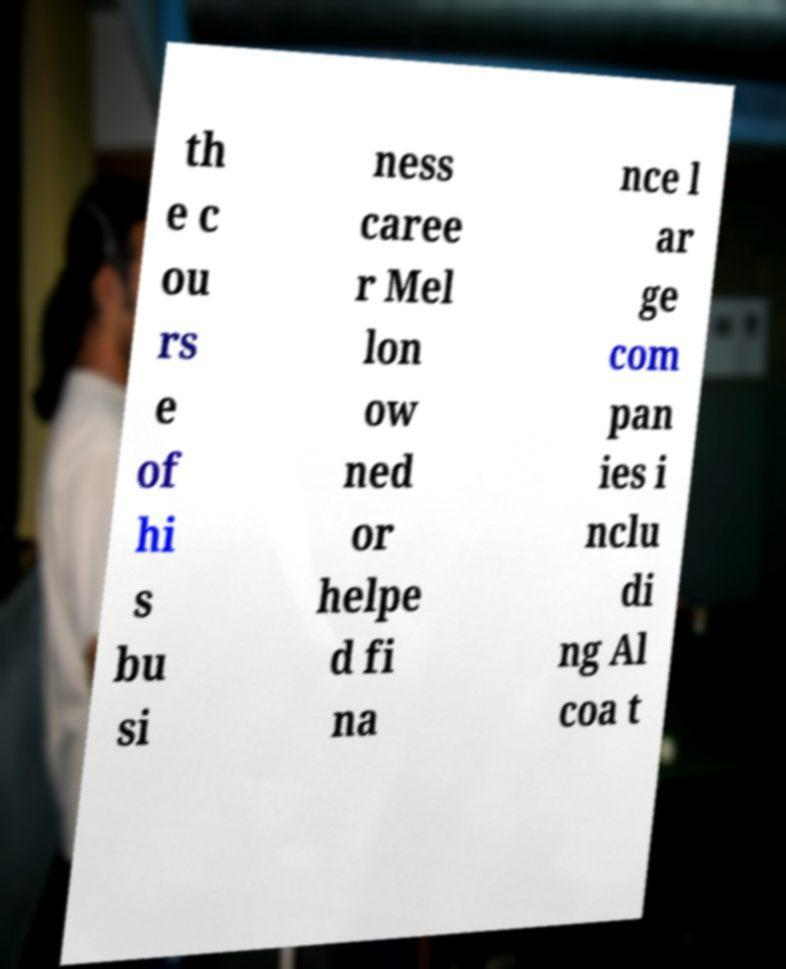Can you accurately transcribe the text from the provided image for me? th e c ou rs e of hi s bu si ness caree r Mel lon ow ned or helpe d fi na nce l ar ge com pan ies i nclu di ng Al coa t 